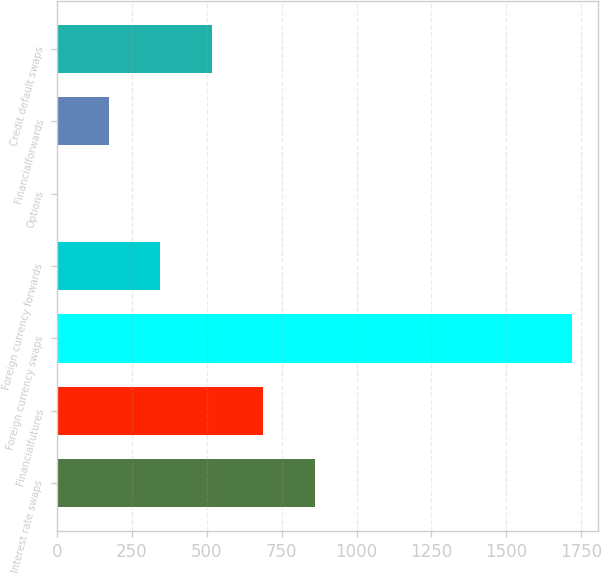<chart> <loc_0><loc_0><loc_500><loc_500><bar_chart><fcel>Interest rate swaps<fcel>Financialfutures<fcel>Foreign currency swaps<fcel>Foreign currency forwards<fcel>Options<fcel>Financialforwards<fcel>Credit default swaps<nl><fcel>860<fcel>688.2<fcel>1719<fcel>344.6<fcel>1<fcel>172.8<fcel>516.4<nl></chart> 